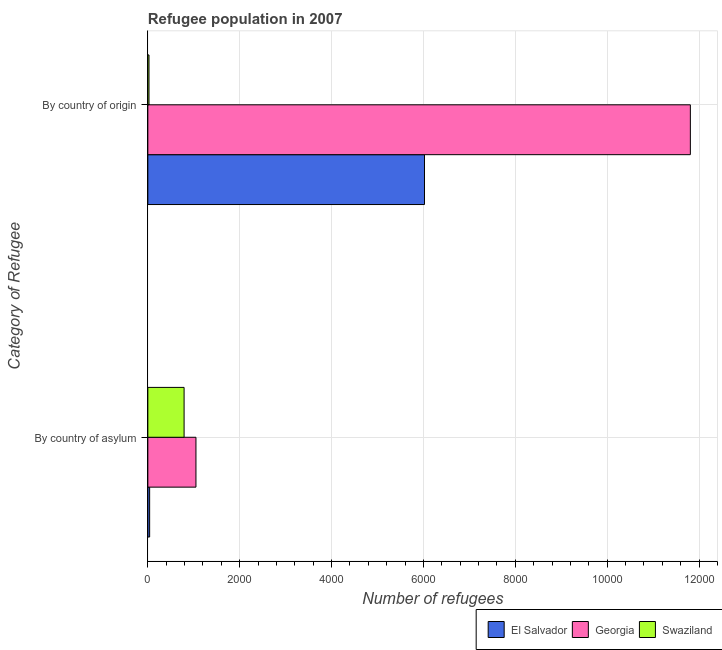Are the number of bars per tick equal to the number of legend labels?
Your answer should be compact. Yes. How many bars are there on the 1st tick from the bottom?
Make the answer very short. 3. What is the label of the 1st group of bars from the top?
Keep it short and to the point. By country of origin. What is the number of refugees by country of asylum in Swaziland?
Provide a succinct answer. 789. Across all countries, what is the maximum number of refugees by country of origin?
Keep it short and to the point. 1.18e+04. Across all countries, what is the minimum number of refugees by country of origin?
Your answer should be very brief. 25. In which country was the number of refugees by country of asylum maximum?
Your response must be concise. Georgia. In which country was the number of refugees by country of origin minimum?
Offer a very short reply. Swaziland. What is the total number of refugees by country of origin in the graph?
Ensure brevity in your answer.  1.79e+04. What is the difference between the number of refugees by country of asylum in Georgia and that in El Salvador?
Keep it short and to the point. 1008. What is the difference between the number of refugees by country of origin in El Salvador and the number of refugees by country of asylum in Georgia?
Provide a succinct answer. 4975. What is the average number of refugees by country of asylum per country?
Ensure brevity in your answer.  625. What is the difference between the number of refugees by country of origin and number of refugees by country of asylum in El Salvador?
Keep it short and to the point. 5983. In how many countries, is the number of refugees by country of origin greater than 3200 ?
Offer a terse response. 2. What is the ratio of the number of refugees by country of origin in Georgia to that in El Salvador?
Provide a succinct answer. 1.96. What does the 3rd bar from the top in By country of origin represents?
Provide a short and direct response. El Salvador. What does the 3rd bar from the bottom in By country of origin represents?
Provide a short and direct response. Swaziland. How many bars are there?
Your response must be concise. 6. What is the difference between two consecutive major ticks on the X-axis?
Make the answer very short. 2000. Are the values on the major ticks of X-axis written in scientific E-notation?
Your answer should be compact. No. Does the graph contain any zero values?
Offer a terse response. No. Does the graph contain grids?
Offer a terse response. Yes. What is the title of the graph?
Ensure brevity in your answer.  Refugee population in 2007. What is the label or title of the X-axis?
Provide a succinct answer. Number of refugees. What is the label or title of the Y-axis?
Keep it short and to the point. Category of Refugee. What is the Number of refugees in Georgia in By country of asylum?
Keep it short and to the point. 1047. What is the Number of refugees in Swaziland in By country of asylum?
Keep it short and to the point. 789. What is the Number of refugees in El Salvador in By country of origin?
Your answer should be very brief. 6022. What is the Number of refugees in Georgia in By country of origin?
Provide a succinct answer. 1.18e+04. What is the Number of refugees in Swaziland in By country of origin?
Give a very brief answer. 25. Across all Category of Refugee, what is the maximum Number of refugees in El Salvador?
Offer a very short reply. 6022. Across all Category of Refugee, what is the maximum Number of refugees of Georgia?
Ensure brevity in your answer.  1.18e+04. Across all Category of Refugee, what is the maximum Number of refugees of Swaziland?
Your answer should be very brief. 789. Across all Category of Refugee, what is the minimum Number of refugees in Georgia?
Your response must be concise. 1047. What is the total Number of refugees in El Salvador in the graph?
Provide a succinct answer. 6061. What is the total Number of refugees in Georgia in the graph?
Your answer should be compact. 1.29e+04. What is the total Number of refugees in Swaziland in the graph?
Ensure brevity in your answer.  814. What is the difference between the Number of refugees in El Salvador in By country of asylum and that in By country of origin?
Your answer should be very brief. -5983. What is the difference between the Number of refugees of Georgia in By country of asylum and that in By country of origin?
Your response must be concise. -1.08e+04. What is the difference between the Number of refugees in Swaziland in By country of asylum and that in By country of origin?
Make the answer very short. 764. What is the difference between the Number of refugees in El Salvador in By country of asylum and the Number of refugees in Georgia in By country of origin?
Keep it short and to the point. -1.18e+04. What is the difference between the Number of refugees of Georgia in By country of asylum and the Number of refugees of Swaziland in By country of origin?
Your answer should be compact. 1022. What is the average Number of refugees in El Salvador per Category of Refugee?
Offer a very short reply. 3030.5. What is the average Number of refugees of Georgia per Category of Refugee?
Ensure brevity in your answer.  6428.5. What is the average Number of refugees in Swaziland per Category of Refugee?
Provide a succinct answer. 407. What is the difference between the Number of refugees in El Salvador and Number of refugees in Georgia in By country of asylum?
Your answer should be very brief. -1008. What is the difference between the Number of refugees of El Salvador and Number of refugees of Swaziland in By country of asylum?
Provide a short and direct response. -750. What is the difference between the Number of refugees in Georgia and Number of refugees in Swaziland in By country of asylum?
Give a very brief answer. 258. What is the difference between the Number of refugees of El Salvador and Number of refugees of Georgia in By country of origin?
Provide a succinct answer. -5788. What is the difference between the Number of refugees in El Salvador and Number of refugees in Swaziland in By country of origin?
Offer a terse response. 5997. What is the difference between the Number of refugees of Georgia and Number of refugees of Swaziland in By country of origin?
Provide a succinct answer. 1.18e+04. What is the ratio of the Number of refugees in El Salvador in By country of asylum to that in By country of origin?
Your answer should be very brief. 0.01. What is the ratio of the Number of refugees of Georgia in By country of asylum to that in By country of origin?
Give a very brief answer. 0.09. What is the ratio of the Number of refugees in Swaziland in By country of asylum to that in By country of origin?
Provide a succinct answer. 31.56. What is the difference between the highest and the second highest Number of refugees of El Salvador?
Give a very brief answer. 5983. What is the difference between the highest and the second highest Number of refugees of Georgia?
Ensure brevity in your answer.  1.08e+04. What is the difference between the highest and the second highest Number of refugees of Swaziland?
Your response must be concise. 764. What is the difference between the highest and the lowest Number of refugees in El Salvador?
Make the answer very short. 5983. What is the difference between the highest and the lowest Number of refugees in Georgia?
Your answer should be compact. 1.08e+04. What is the difference between the highest and the lowest Number of refugees in Swaziland?
Offer a very short reply. 764. 